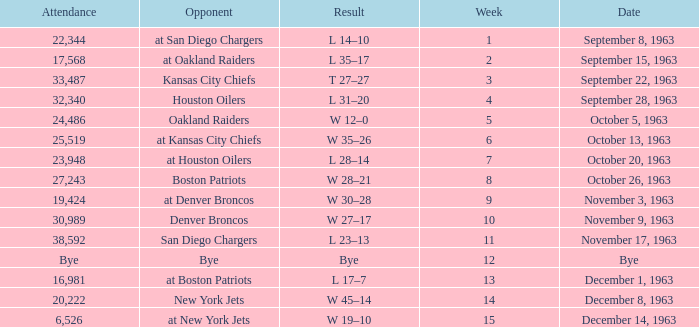Which adversary has a date corresponding to november 17, 1963? San Diego Chargers. 